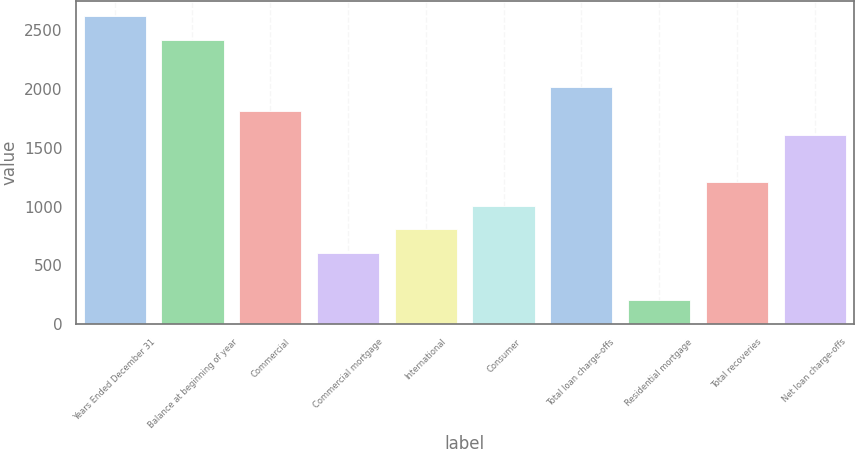Convert chart. <chart><loc_0><loc_0><loc_500><loc_500><bar_chart><fcel>Years Ended December 31<fcel>Balance at beginning of year<fcel>Commercial<fcel>Commercial mortgage<fcel>International<fcel>Consumer<fcel>Total loan charge-offs<fcel>Residential mortgage<fcel>Total recoveries<fcel>Net loan charge-offs<nl><fcel>2622.03<fcel>2420.35<fcel>1815.31<fcel>605.23<fcel>806.91<fcel>1008.59<fcel>2016.99<fcel>201.87<fcel>1210.27<fcel>1613.63<nl></chart> 